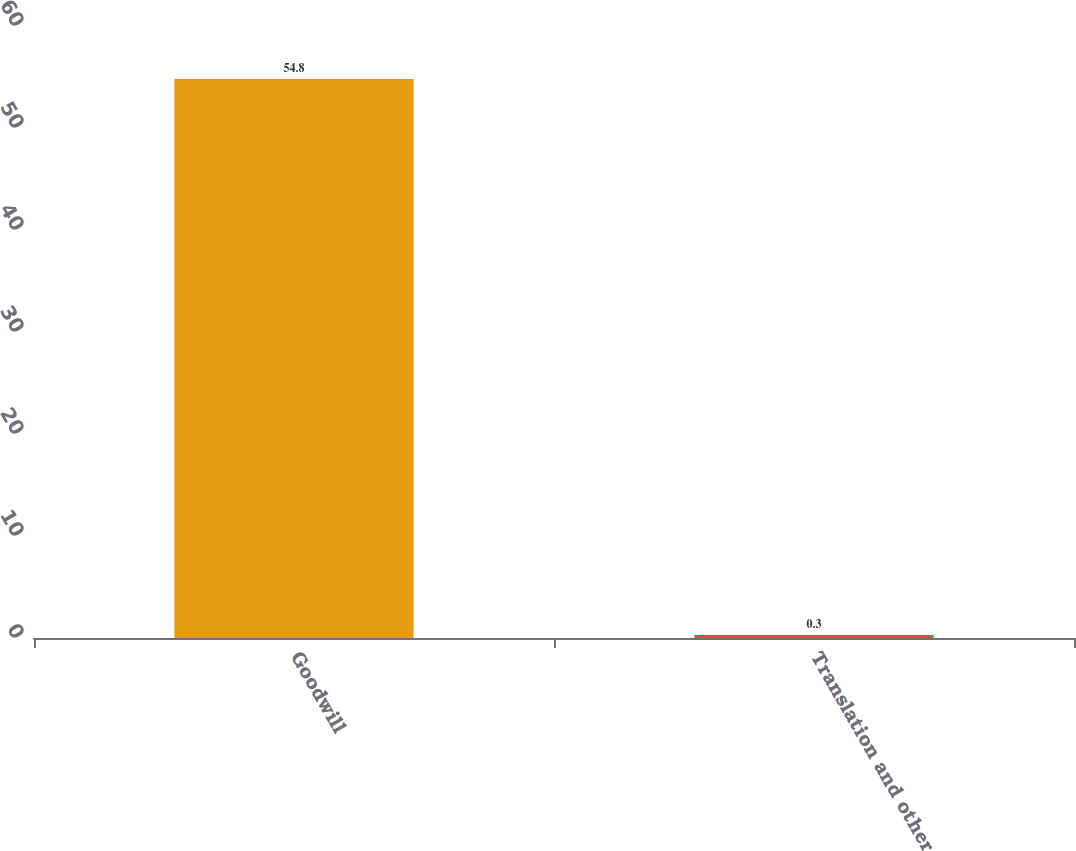<chart> <loc_0><loc_0><loc_500><loc_500><bar_chart><fcel>Goodwill<fcel>Translation and other<nl><fcel>54.8<fcel>0.3<nl></chart> 